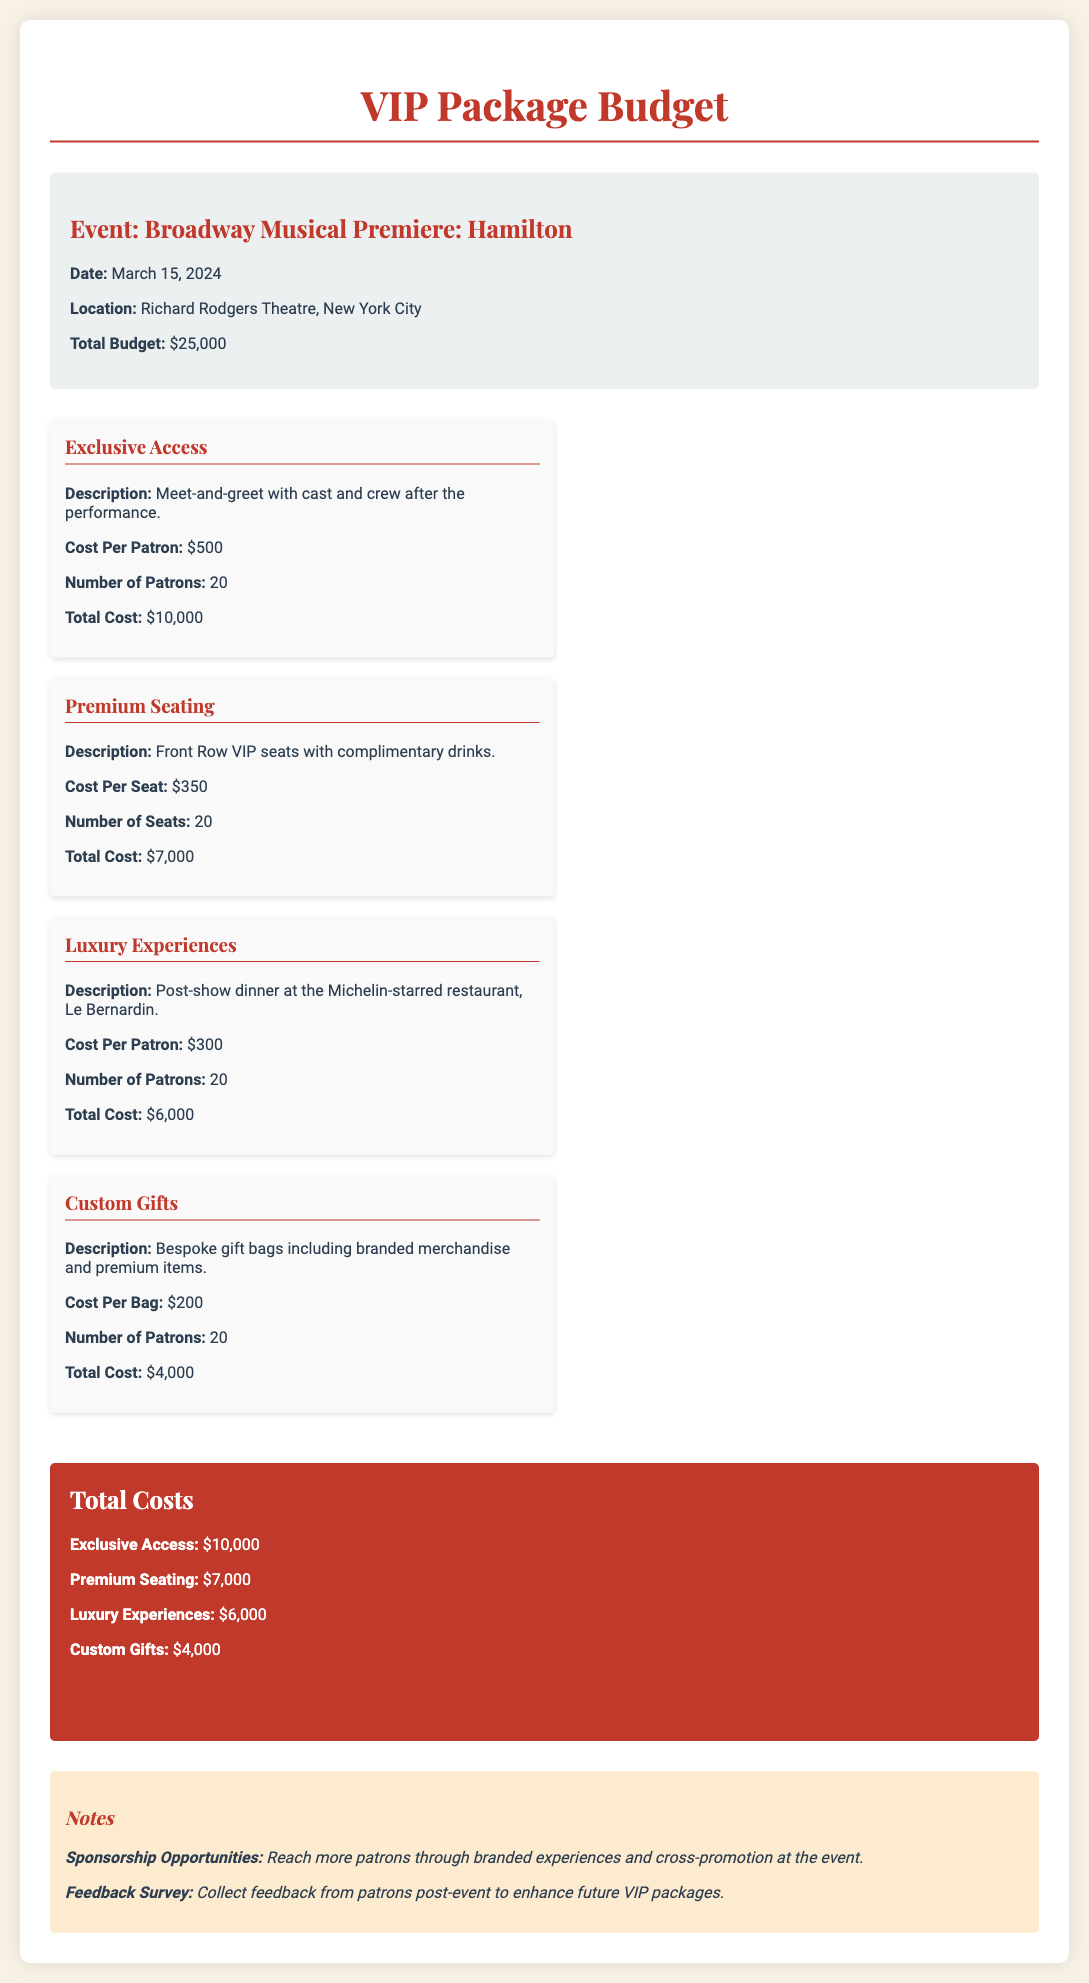What is the event name? The event name is stated in the document's title section, which indicates it is a Broadway Musical Premiere: Hamilton.
Answer: Broadway Musical Premiere: Hamilton What is the total budget? The total budget is explicitly mentioned in the event details section as $25,000.
Answer: $25,000 How many patrons are included in the exclusive access package? The number of patrons for exclusive access is provided in the breakdown for that section, which states 20 patrons.
Answer: 20 What is the total cost for premium seating? The total cost for premium seating is calculated in the budget breakdown and shown as $7,000.
Answer: $7,000 What luxury experience is offered in the package? The document describes the luxury experience as a post-show dinner at the Michelin-starred restaurant, Le Bernardin.
Answer: Post-show dinner at Le Bernardin How much does each bespoke gift bag cost? The document lists the cost per bespoke gift bag as $200 in the Custom Gifts section.
Answer: $200 What is the grand total of the package? The grand total is summarized in the total costs section of the document, which indicates $32,000.
Answer: $32,000 What type of feedback will be collected post-event? The document states that a feedback survey will be collected from patrons to enhance future VIP packages.
Answer: Feedback survey How much is the cost per patron for luxury experiences? The document specifies the cost per patron for luxury experiences as $300 in the breakdown section.
Answer: $300 